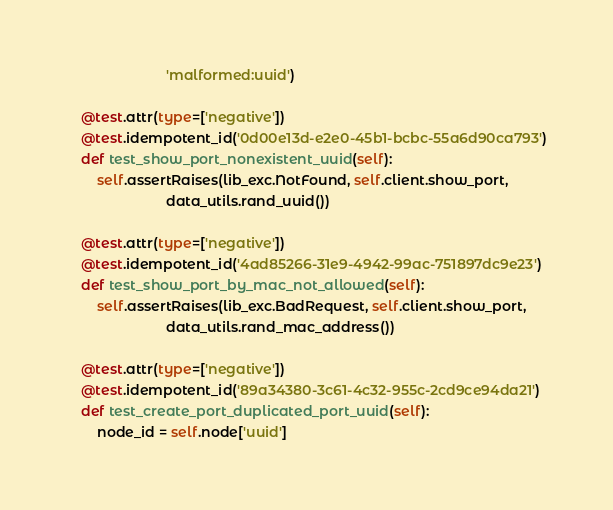Convert code to text. <code><loc_0><loc_0><loc_500><loc_500><_Python_>                          'malformed:uuid')

    @test.attr(type=['negative'])
    @test.idempotent_id('0d00e13d-e2e0-45b1-bcbc-55a6d90ca793')
    def test_show_port_nonexistent_uuid(self):
        self.assertRaises(lib_exc.NotFound, self.client.show_port,
                          data_utils.rand_uuid())

    @test.attr(type=['negative'])
    @test.idempotent_id('4ad85266-31e9-4942-99ac-751897dc9e23')
    def test_show_port_by_mac_not_allowed(self):
        self.assertRaises(lib_exc.BadRequest, self.client.show_port,
                          data_utils.rand_mac_address())

    @test.attr(type=['negative'])
    @test.idempotent_id('89a34380-3c61-4c32-955c-2cd9ce94da21')
    def test_create_port_duplicated_port_uuid(self):
        node_id = self.node['uuid']</code> 